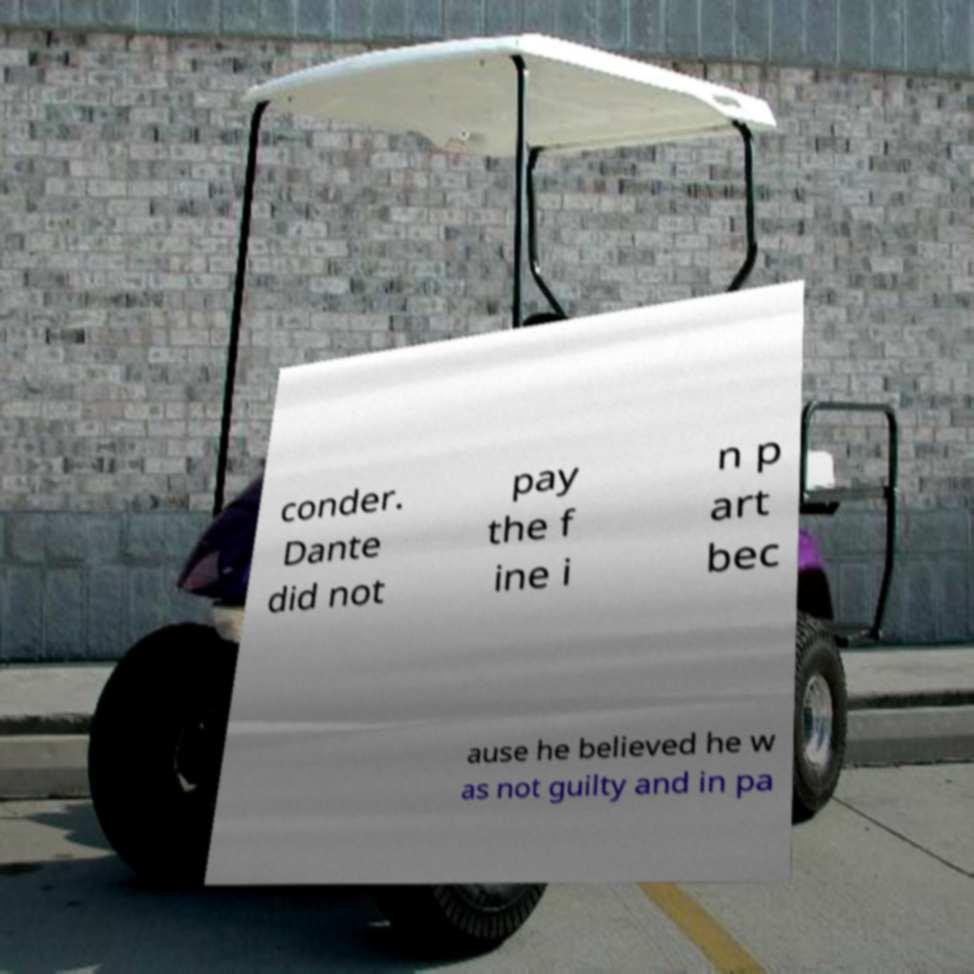There's text embedded in this image that I need extracted. Can you transcribe it verbatim? conder. Dante did not pay the f ine i n p art bec ause he believed he w as not guilty and in pa 